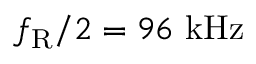Convert formula to latex. <formula><loc_0><loc_0><loc_500><loc_500>f _ { R } / 2 = 9 6 k H z</formula> 